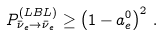<formula> <loc_0><loc_0><loc_500><loc_500>P _ { \bar { \nu } _ { e } \to \bar { \nu } _ { e } } ^ { ( L B L ) } \geq \left ( 1 - a _ { e } ^ { 0 } \right ) ^ { 2 } \, .</formula> 